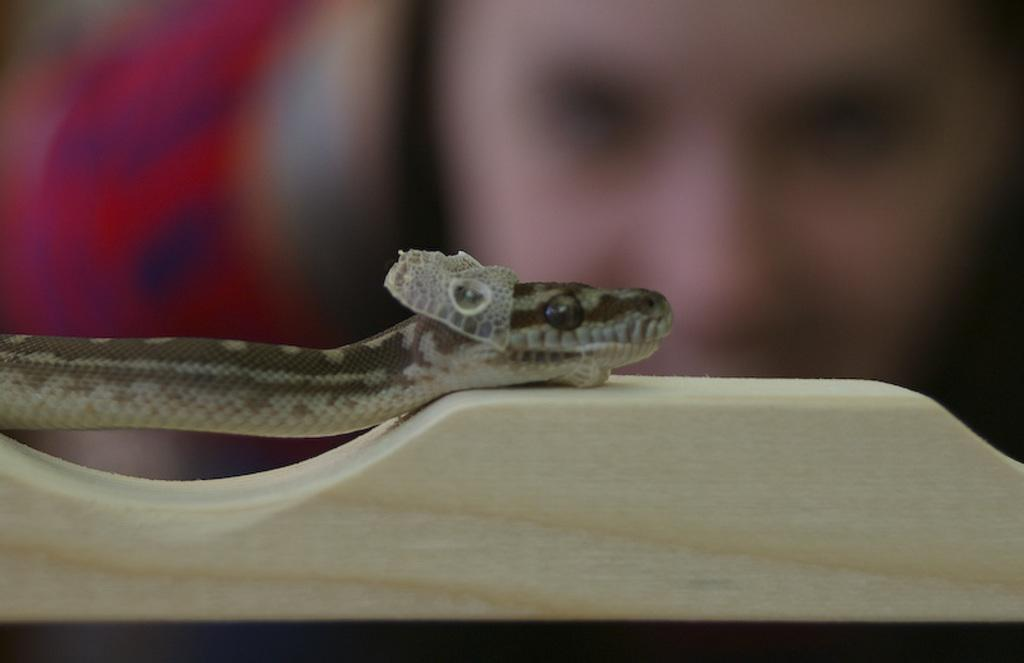What animal is present in the image? There is a snake in the image. What is the snake resting on in the image? The snake is on a wooden object. Can you describe the background of the image? The background of the image is blurred. What type of cracker is being sold in the image? There is no cracker present in the image; it features a snake on a wooden object with a blurred background. 